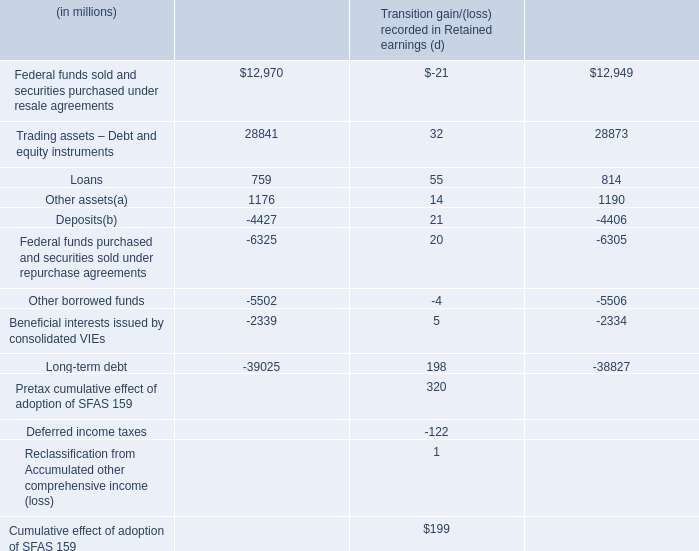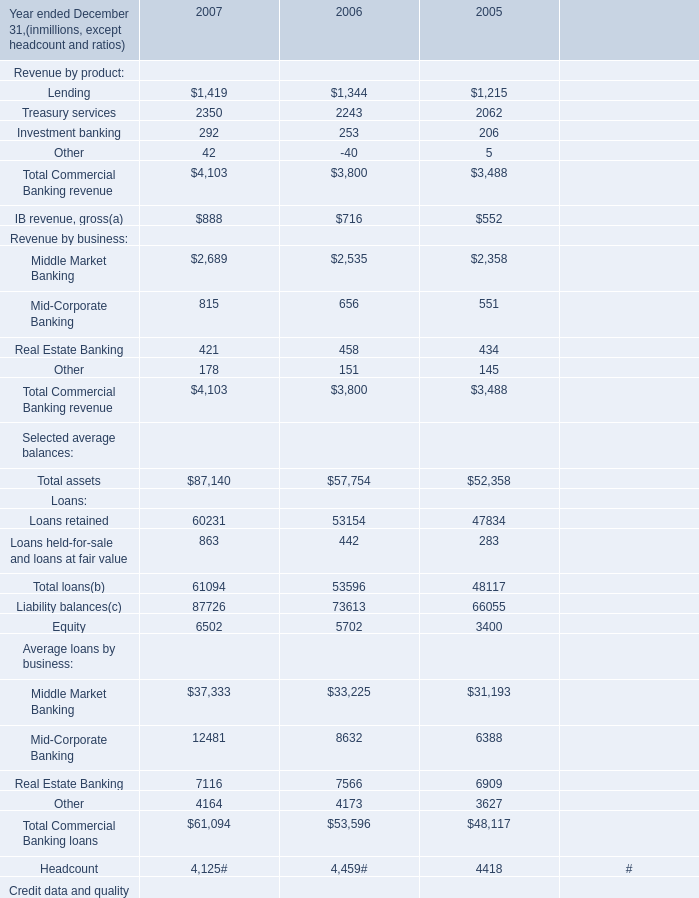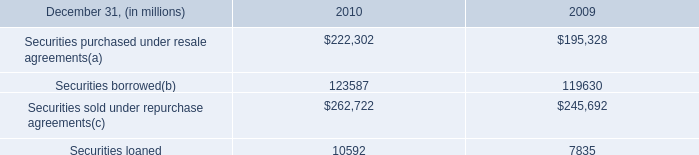What is the average amount of Securities loaned of 2009, and Treasury services of 2005 ? 
Computations: ((7835.0 + 2062.0) / 2)
Answer: 4948.5. Which year is Total Commercial Banking revenue the most? 
Answer: 2007. 